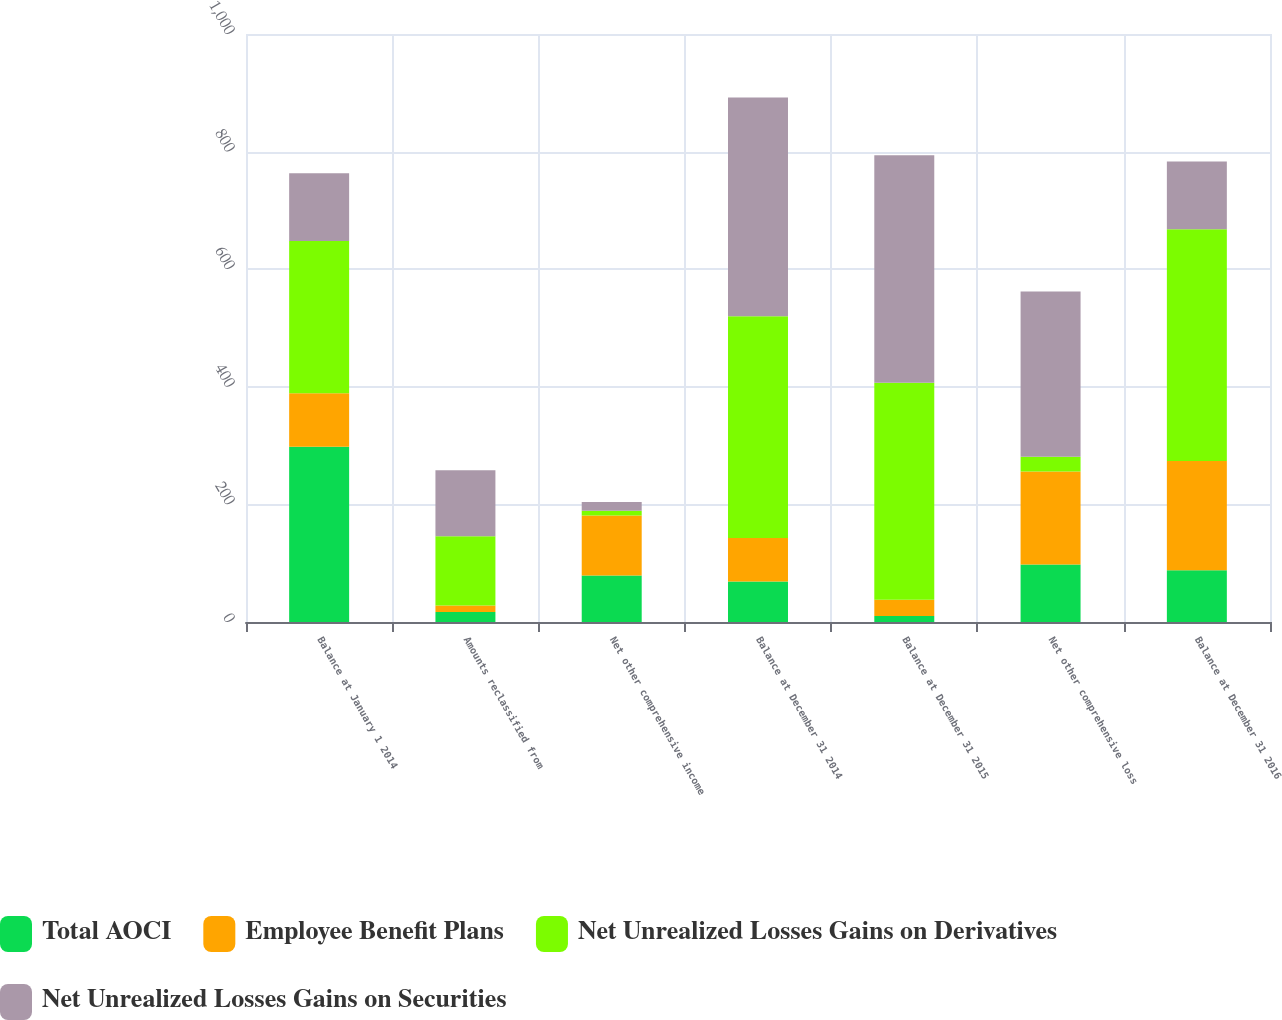<chart> <loc_0><loc_0><loc_500><loc_500><stacked_bar_chart><ecel><fcel>Balance at January 1 2014<fcel>Amounts reclassified from<fcel>Net other comprehensive income<fcel>Balance at December 31 2014<fcel>Balance at December 31 2015<fcel>Net other comprehensive loss<fcel>Balance at December 31 2016<nl><fcel>Total AOCI<fcel>298<fcel>17<fcel>79<fcel>69<fcel>10<fcel>98<fcel>88<nl><fcel>Employee Benefit Plans<fcel>91<fcel>11<fcel>102<fcel>74<fcel>28<fcel>158<fcel>186<nl><fcel>Net Unrealized Losses Gains on Derivatives<fcel>259<fcel>118<fcel>8<fcel>377<fcel>369<fcel>25<fcel>394<nl><fcel>Net Unrealized Losses Gains on Securities<fcel>115<fcel>112<fcel>15<fcel>372<fcel>387<fcel>281<fcel>115<nl></chart> 